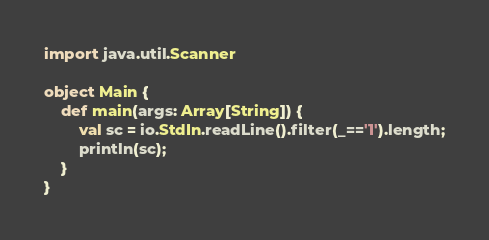<code> <loc_0><loc_0><loc_500><loc_500><_Scala_>import java.util.Scanner

object Main {
    def main(args: Array[String]) {
        val sc = io.StdIn.readLine().filter(_=='1').length;
        println(sc);
    }
}</code> 